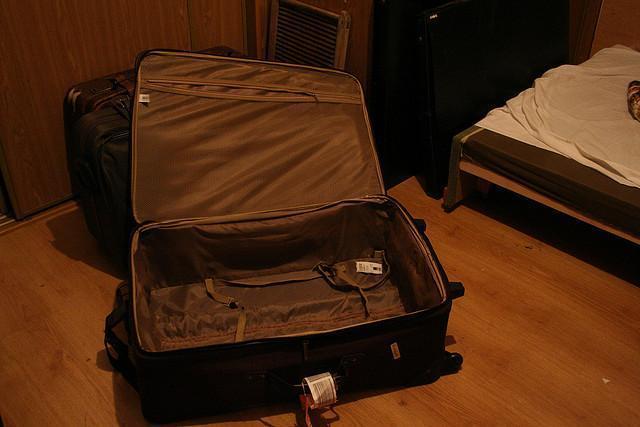How many suitcases in the photo?
Give a very brief answer. 2. How many suitcases are shown?
Give a very brief answer. 2. How many hard suitcases that are blue are there?
Give a very brief answer. 0. How many pairs of shoes are under the bed?
Give a very brief answer. 0. How many suitcases can be seen?
Give a very brief answer. 2. How many polar bears are present?
Give a very brief answer. 0. 